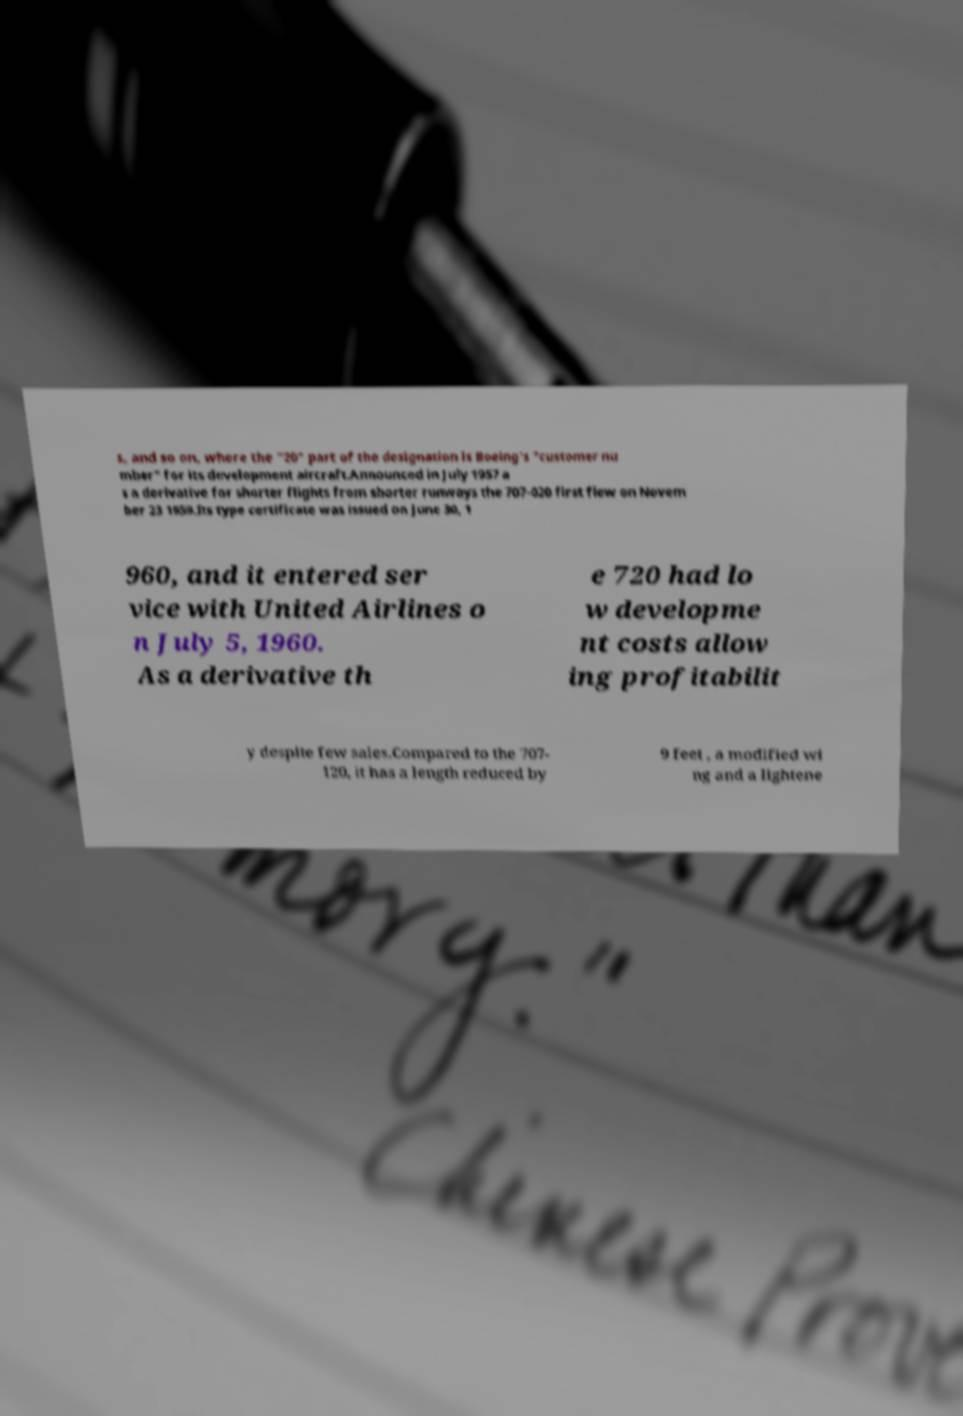For documentation purposes, I need the text within this image transcribed. Could you provide that? s, and so on, where the "20" part of the designation is Boeing's "customer nu mber" for its development aircraft.Announced in July 1957 a s a derivative for shorter flights from shorter runways the 707-020 first flew on Novem ber 23 1959.Its type certificate was issued on June 30, 1 960, and it entered ser vice with United Airlines o n July 5, 1960. As a derivative th e 720 had lo w developme nt costs allow ing profitabilit y despite few sales.Compared to the 707- 120, it has a length reduced by 9 feet , a modified wi ng and a lightene 